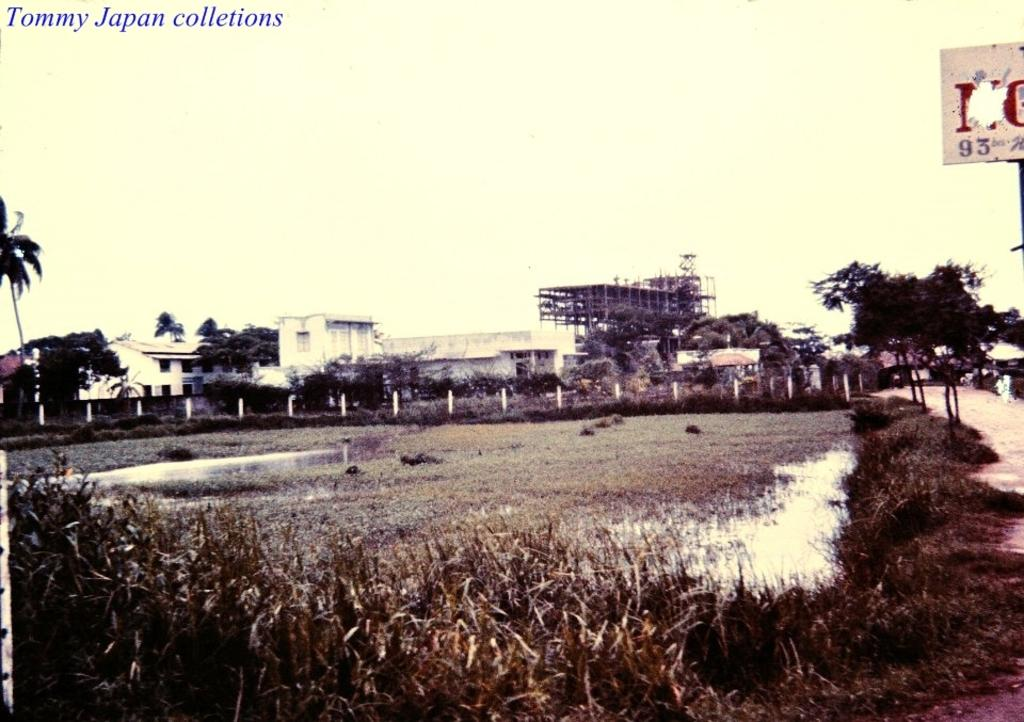What is one of the natural elements present in the image? There is water in the image. What type of vegetation can be seen in the image? There is grass and trees in the image. What type of man-made structures are visible in the image? There are buildings in the image. What are the poles used for in the image? The purpose of the poles is not specified in the image, but they could be used for various purposes such as lighting or signage. What is the board used for in the image? The purpose of the board is not specified in the image, but it could be used for displaying information or as a surface for writing or drawing. What is visible in the sky in the image? The sky is visible in the image, but no specific weather conditions or celestial bodies are mentioned. What is the watermark in the top left corner of the image? The watermark is a mark or logo that indicates ownership or copyright, but its specific details are not mentioned in the image. What time of day is it in the image, and is there a wrench visible? The time of day is not specified in the image, and there is no wrench visible. 